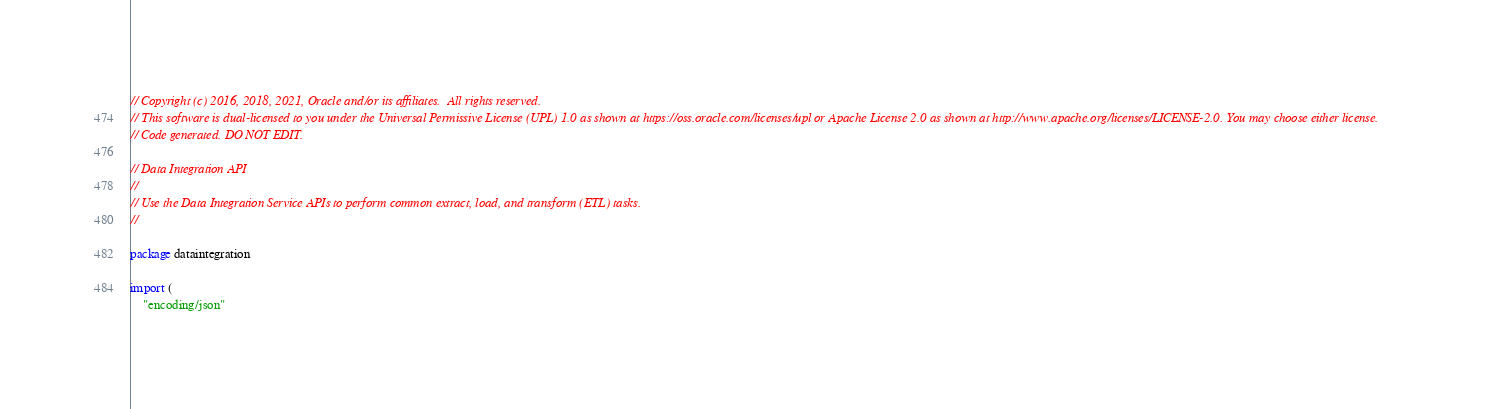<code> <loc_0><loc_0><loc_500><loc_500><_Go_>// Copyright (c) 2016, 2018, 2021, Oracle and/or its affiliates.  All rights reserved.
// This software is dual-licensed to you under the Universal Permissive License (UPL) 1.0 as shown at https://oss.oracle.com/licenses/upl or Apache License 2.0 as shown at http://www.apache.org/licenses/LICENSE-2.0. You may choose either license.
// Code generated. DO NOT EDIT.

// Data Integration API
//
// Use the Data Integration Service APIs to perform common extract, load, and transform (ETL) tasks.
//

package dataintegration

import (
	"encoding/json"</code> 